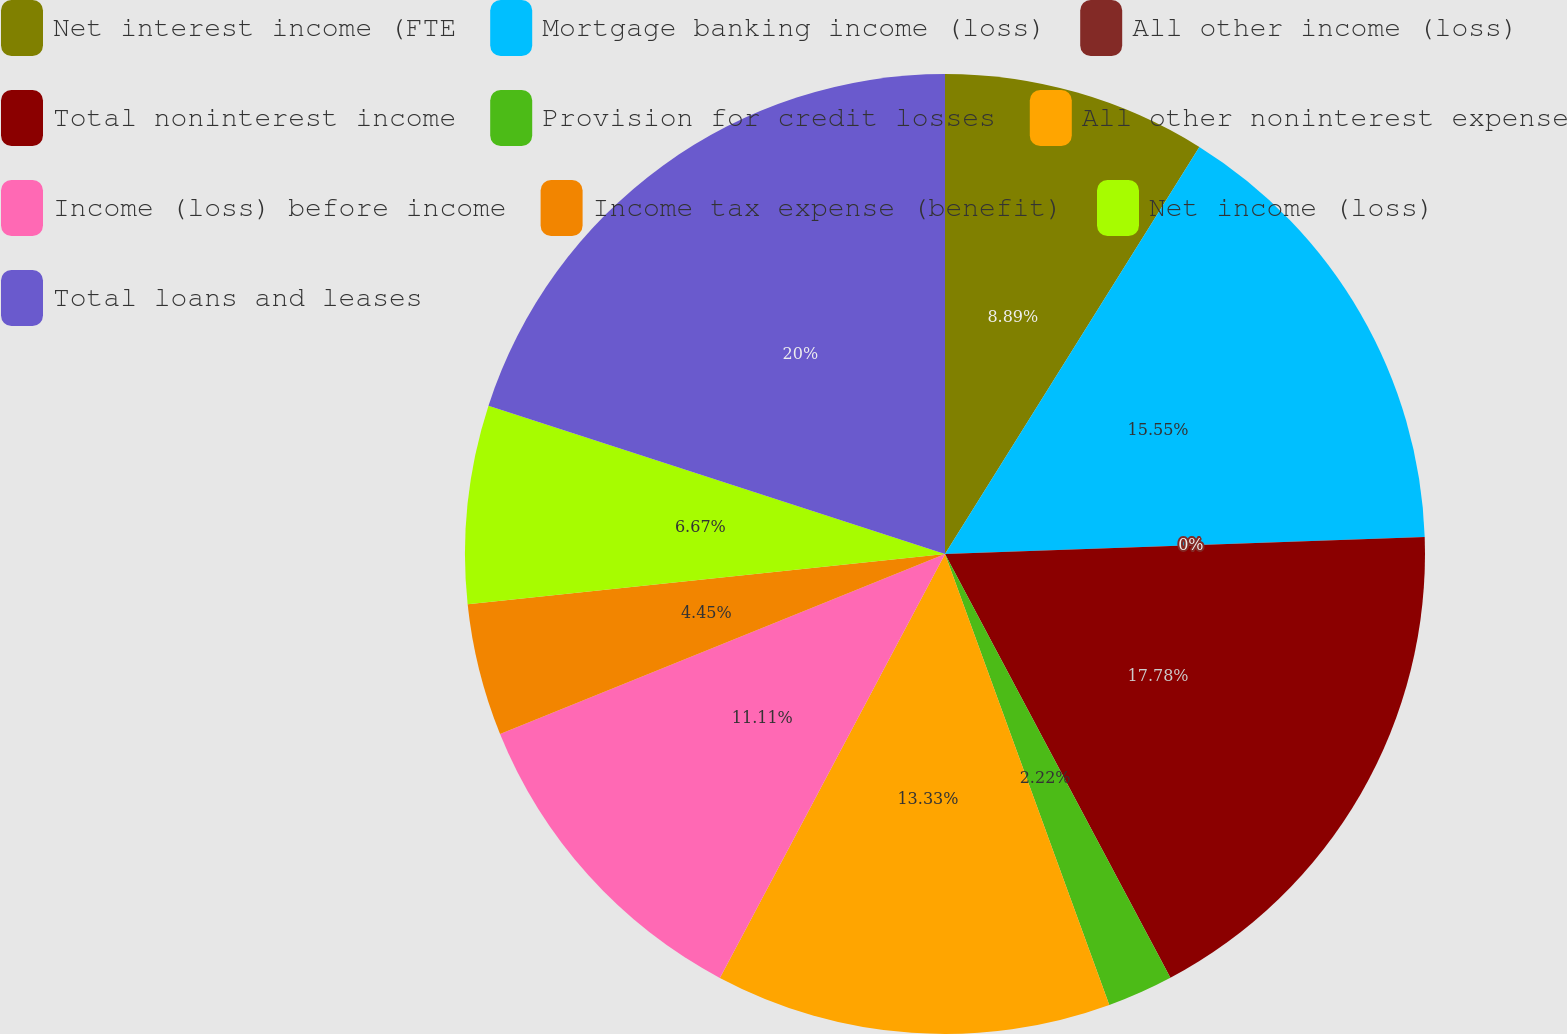<chart> <loc_0><loc_0><loc_500><loc_500><pie_chart><fcel>Net interest income (FTE<fcel>Mortgage banking income (loss)<fcel>All other income (loss)<fcel>Total noninterest income<fcel>Provision for credit losses<fcel>All other noninterest expense<fcel>Income (loss) before income<fcel>Income tax expense (benefit)<fcel>Net income (loss)<fcel>Total loans and leases<nl><fcel>8.89%<fcel>15.55%<fcel>0.0%<fcel>17.78%<fcel>2.22%<fcel>13.33%<fcel>11.11%<fcel>4.45%<fcel>6.67%<fcel>20.0%<nl></chart> 